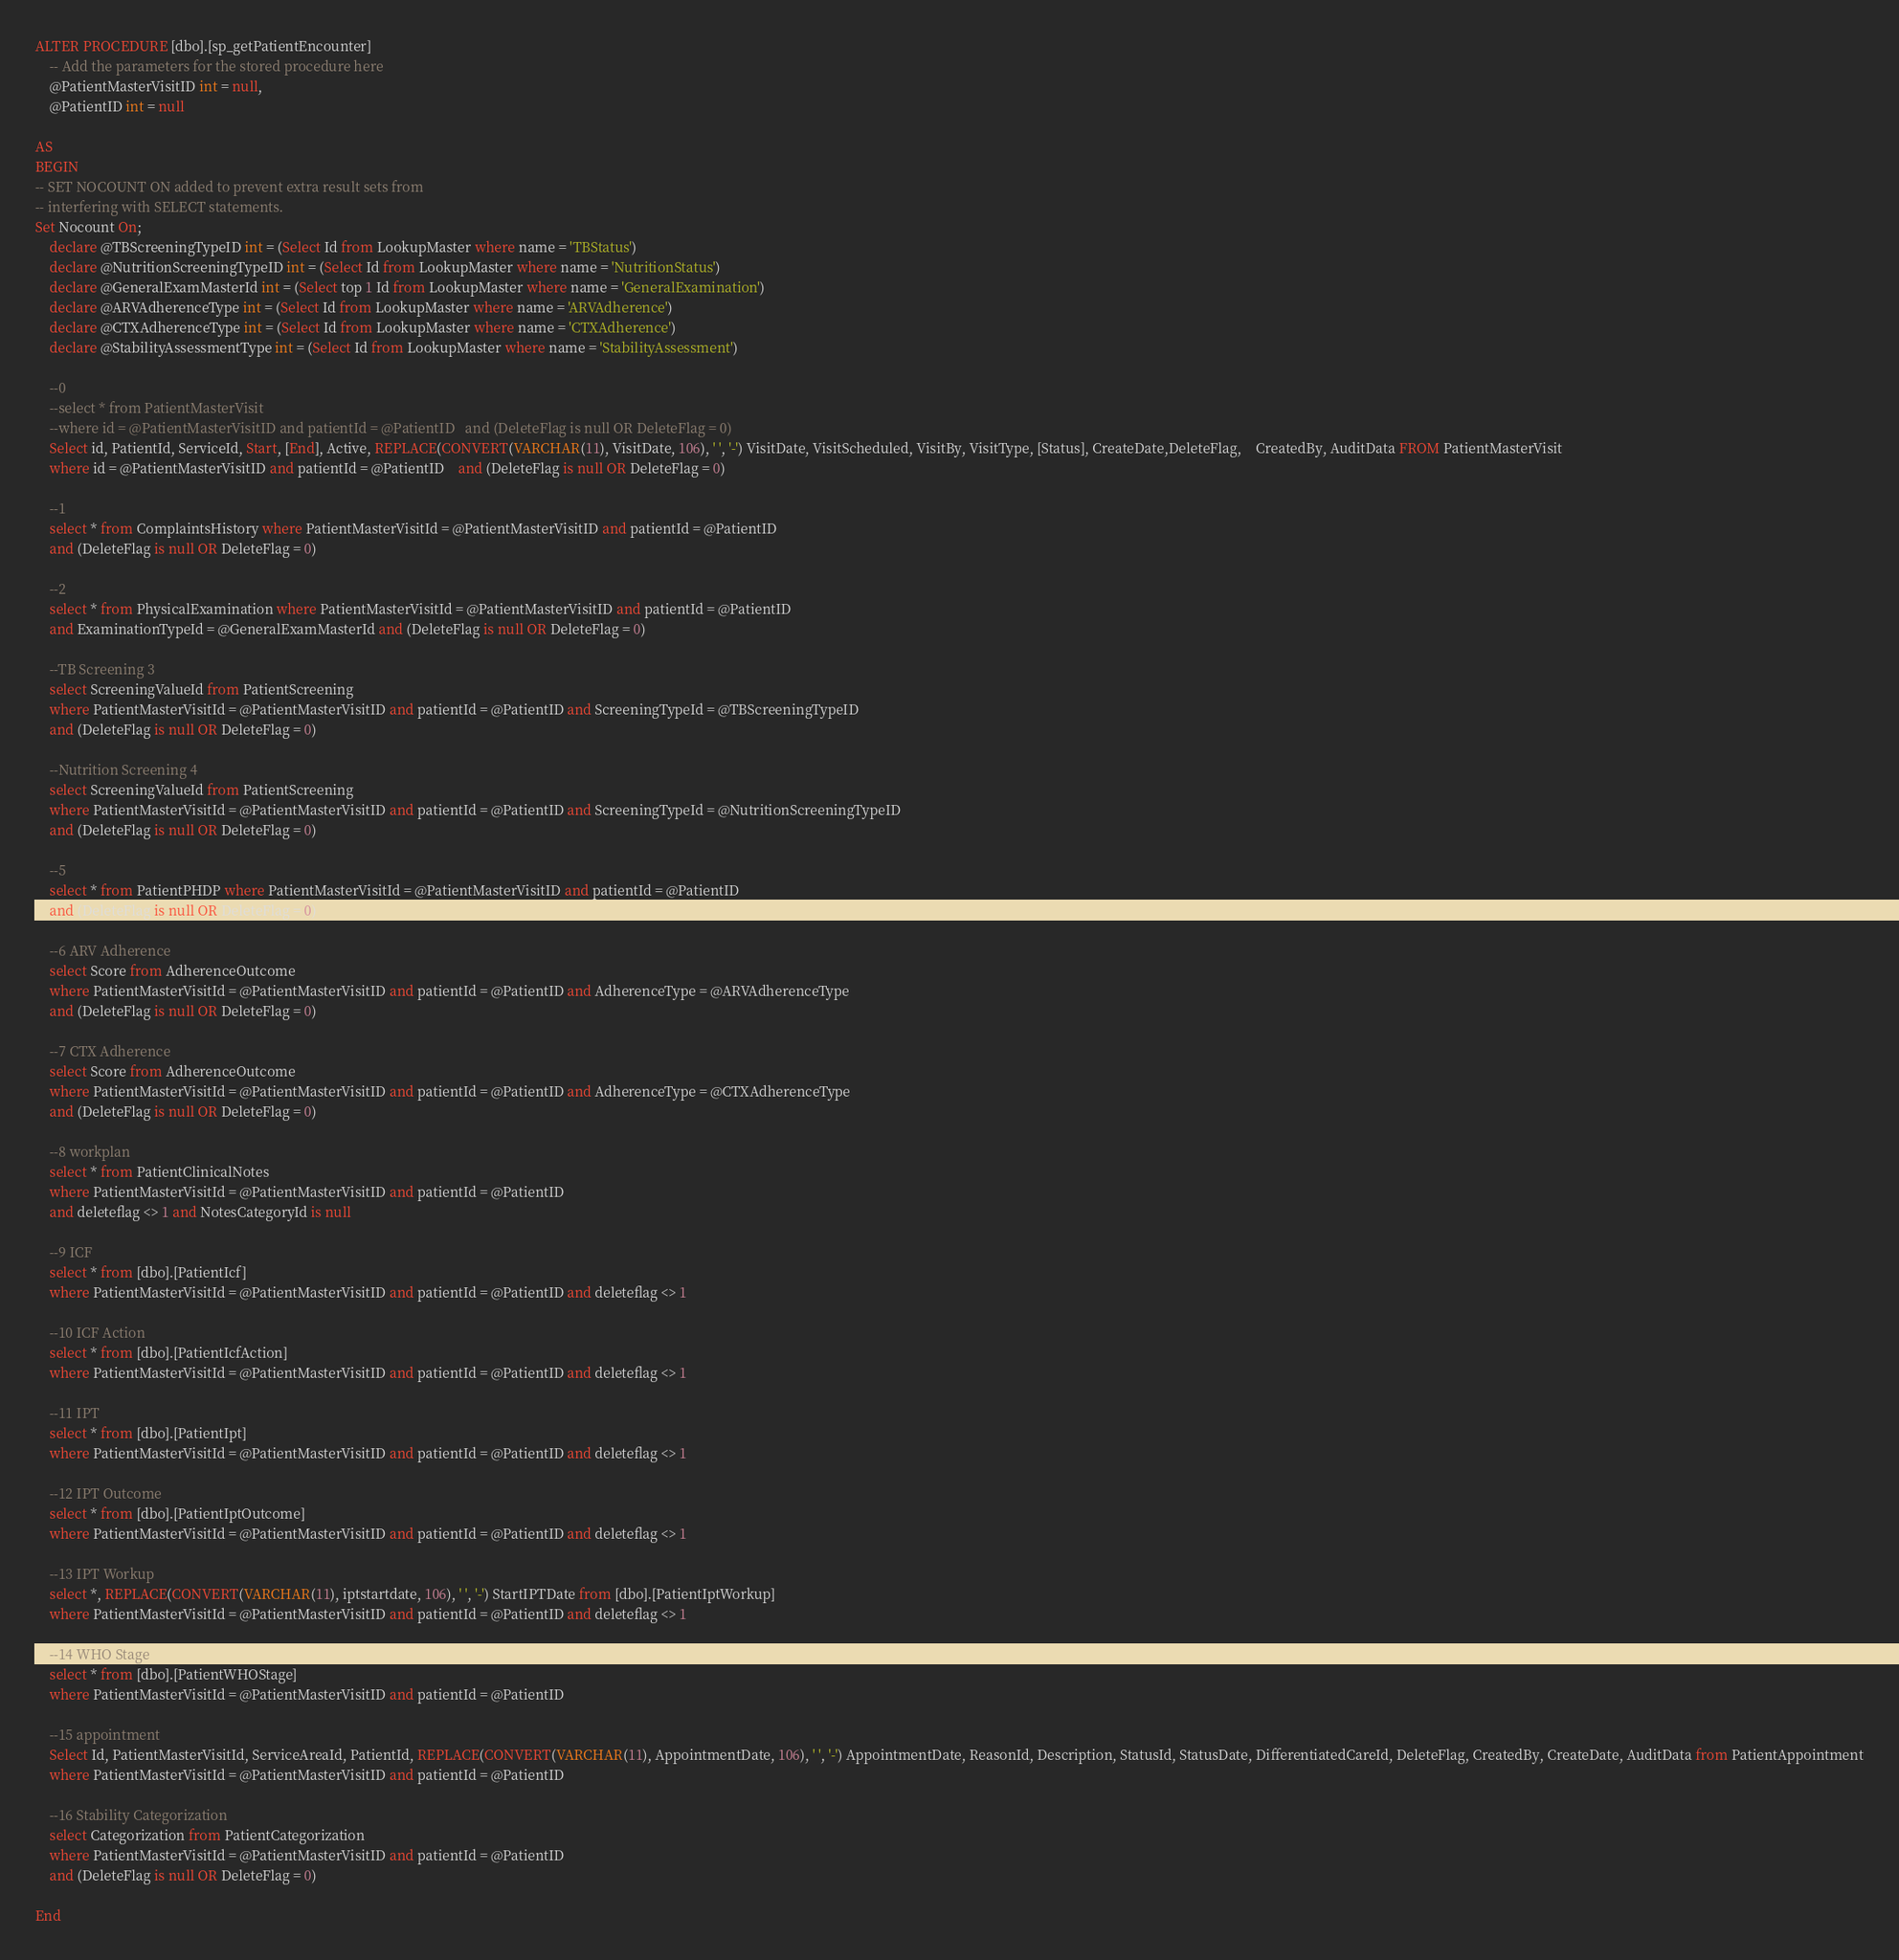Convert code to text. <code><loc_0><loc_0><loc_500><loc_500><_SQL_>

ALTER PROCEDURE [dbo].[sp_getPatientEncounter]
	-- Add the parameters for the stored procedure here
	@PatientMasterVisitID int = null,
	@PatientID int = null

AS
BEGIN
-- SET NOCOUNT ON added to prevent extra result sets from
-- interfering with SELECT statements.
Set Nocount On;
	declare @TBScreeningTypeID int = (Select Id from LookupMaster where name = 'TBStatus')
	declare @NutritionScreeningTypeID int = (Select Id from LookupMaster where name = 'NutritionStatus')
	declare @GeneralExamMasterId int = (Select top 1 Id from LookupMaster where name = 'GeneralExamination')
	declare @ARVAdherenceType int = (Select Id from LookupMaster where name = 'ARVAdherence')
	declare @CTXAdherenceType int = (Select Id from LookupMaster where name = 'CTXAdherence')
	declare @StabilityAssessmentType int = (Select Id from LookupMaster where name = 'StabilityAssessment')

	--0
	--select * from PatientMasterVisit 
	--where id = @PatientMasterVisitID and patientId = @PatientID	and (DeleteFlag is null OR DeleteFlag = 0)
	Select id, PatientId, ServiceId, Start, [End], Active, REPLACE(CONVERT(VARCHAR(11), VisitDate, 106), ' ', '-') VisitDate, VisitScheduled, VisitBy, VisitType, [Status], CreateDate,DeleteFlag,	CreatedBy, AuditData FROM PatientMasterVisit
	where id = @PatientMasterVisitID and patientId = @PatientID	and (DeleteFlag is null OR DeleteFlag = 0)
	
	--1
	select * from ComplaintsHistory where PatientMasterVisitId = @PatientMasterVisitID and patientId = @PatientID
	and (DeleteFlag is null OR DeleteFlag = 0)
	
	--2
	select * from PhysicalExamination where PatientMasterVisitId = @PatientMasterVisitID and patientId = @PatientID
	and ExaminationTypeId = @GeneralExamMasterId and (DeleteFlag is null OR DeleteFlag = 0)
	
	--TB Screening 3
	select ScreeningValueId from PatientScreening 
	where PatientMasterVisitId = @PatientMasterVisitID and patientId = @PatientID and ScreeningTypeId = @TBScreeningTypeID
	and (DeleteFlag is null OR DeleteFlag = 0)
	
	--Nutrition Screening 4
	select ScreeningValueId from PatientScreening 
	where PatientMasterVisitId = @PatientMasterVisitID and patientId = @PatientID and ScreeningTypeId = @NutritionScreeningTypeID
	and (DeleteFlag is null OR DeleteFlag = 0)
	
	--5
	select * from PatientPHDP where PatientMasterVisitId = @PatientMasterVisitID and patientId = @PatientID 
	and (DeleteFlag is null OR DeleteFlag = 0)

	--6 ARV Adherence
	select Score from AdherenceOutcome 
	where PatientMasterVisitId = @PatientMasterVisitID and patientId = @PatientID and AdherenceType = @ARVAdherenceType
	and (DeleteFlag is null OR DeleteFlag = 0)

	--7 CTX Adherence
	select Score from AdherenceOutcome 
	where PatientMasterVisitId = @PatientMasterVisitID and patientId = @PatientID and AdherenceType = @CTXAdherenceType
	and (DeleteFlag is null OR DeleteFlag = 0)

	--8 workplan
	select * from PatientClinicalNotes
	where PatientMasterVisitId = @PatientMasterVisitID and patientId = @PatientID 
	and deleteflag <> 1 and NotesCategoryId is null

	--9 ICF
	select * from [dbo].[PatientIcf]
	where PatientMasterVisitId = @PatientMasterVisitID and patientId = @PatientID and deleteflag <> 1

	--10 ICF Action
	select * from [dbo].[PatientIcfAction]
	where PatientMasterVisitId = @PatientMasterVisitID and patientId = @PatientID and deleteflag <> 1

	--11 IPT
	select * from [dbo].[PatientIpt]
	where PatientMasterVisitId = @PatientMasterVisitID and patientId = @PatientID and deleteflag <> 1

	--12 IPT Outcome
	select * from [dbo].[PatientIptOutcome]
	where PatientMasterVisitId = @PatientMasterVisitID and patientId = @PatientID and deleteflag <> 1

	--13 IPT Workup
	select *, REPLACE(CONVERT(VARCHAR(11), iptstartdate, 106), ' ', '-') StartIPTDate from [dbo].[PatientIptWorkup]
	where PatientMasterVisitId = @PatientMasterVisitID and patientId = @PatientID and deleteflag <> 1
	
	--14 WHO Stage
	select * from [dbo].[PatientWHOStage]
	where PatientMasterVisitId = @PatientMasterVisitID and patientId = @PatientID

	--15 appointment
	Select Id, PatientMasterVisitId, ServiceAreaId, PatientId, REPLACE(CONVERT(VARCHAR(11), AppointmentDate, 106), ' ', '-') AppointmentDate, ReasonId, Description, StatusId, StatusDate, DifferentiatedCareId, DeleteFlag, CreatedBy, CreateDate, AuditData from PatientAppointment
	where PatientMasterVisitId = @PatientMasterVisitID and patientId = @PatientID

	--16 Stability Categorization
	select Categorization from PatientCategorization 
	where PatientMasterVisitId = @PatientMasterVisitID and patientId = @PatientID
	and (DeleteFlag is null OR DeleteFlag = 0)

End



</code> 